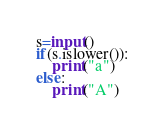<code> <loc_0><loc_0><loc_500><loc_500><_Python_>s=input()
if(s.islower()):
    print("a")
else:
    print("A")
</code> 